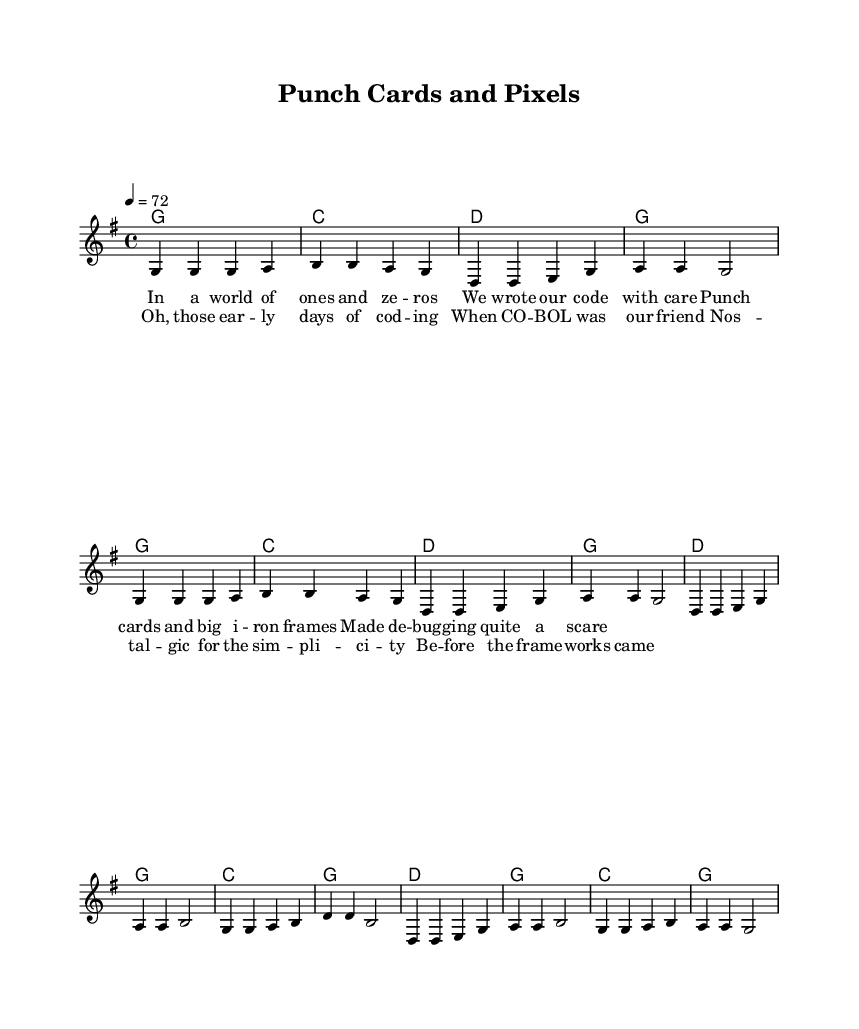What is the key signature of this music? The key signature is G major, which has one sharp (F#). This can be identified from the global section of the code, which indicates a "\key g \major".
Answer: G major What is the time signature of this music? The time signature is 4/4, which means there are four beats in each measure. This is also specified in the global section of the code with "\time 4/4".
Answer: 4/4 What is the tempo marking of this music? The tempo marking is 72 beats per minute (BPM). This can be derived from the "\tempo 4 = 72" statement in the global section, indicating the speed of the piece.
Answer: 72 How many measures are in the verse section? The verse section consists of 8 measures. By counting the vertical lines separating the measures in the melody and harmonies, we identify there are 8 complete measures in the verse.
Answer: 8 What is the first line of the verse lyrics? The first line of the verse lyrics is "In a world of ones and ze -- ros". This is found in the lyrics that are integrated with the melody section of the code under verseOne.
Answer: In a world of ones and ze -- ros What instrument type primarily performs the melody in this sheet music? The melody is primarily performed by a "Voice" instrument type, as indicated by the notation "\new Voice = 'lead' {" in the score section. This suggests that the lead melody is sung or played by a vocalist.
Answer: Voice What common theme is expressed in the chorus lyrics? The common theme expressed in the chorus lyrics is nostalgia for early programming days. Analyzing the text "Oh, those ear -- ly days of cod -- ing" and "Nos -- tal -- gic for the sim -- pli -- ci -- ty" conveys a longing for simpler times in programming, emphasizing a sentiment found in country ballads.
Answer: Nostalgia 